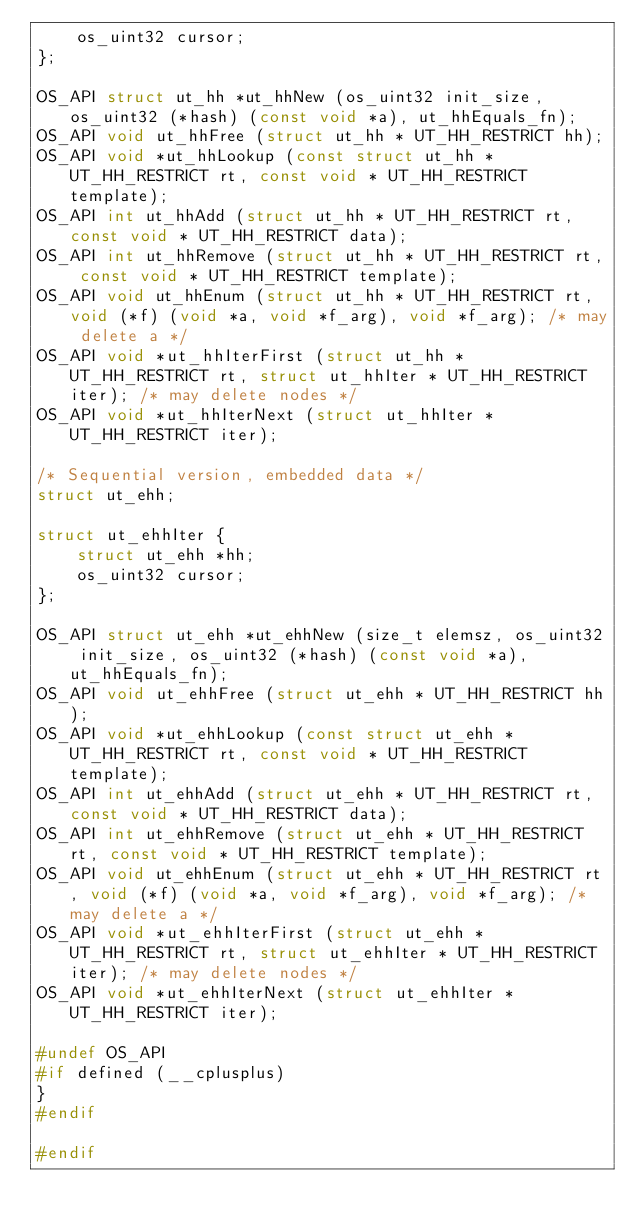<code> <loc_0><loc_0><loc_500><loc_500><_C_>    os_uint32 cursor;
};

OS_API struct ut_hh *ut_hhNew (os_uint32 init_size, os_uint32 (*hash) (const void *a), ut_hhEquals_fn);
OS_API void ut_hhFree (struct ut_hh * UT_HH_RESTRICT hh);
OS_API void *ut_hhLookup (const struct ut_hh * UT_HH_RESTRICT rt, const void * UT_HH_RESTRICT template);
OS_API int ut_hhAdd (struct ut_hh * UT_HH_RESTRICT rt, const void * UT_HH_RESTRICT data);
OS_API int ut_hhRemove (struct ut_hh * UT_HH_RESTRICT rt, const void * UT_HH_RESTRICT template);
OS_API void ut_hhEnum (struct ut_hh * UT_HH_RESTRICT rt, void (*f) (void *a, void *f_arg), void *f_arg); /* may delete a */
OS_API void *ut_hhIterFirst (struct ut_hh * UT_HH_RESTRICT rt, struct ut_hhIter * UT_HH_RESTRICT iter); /* may delete nodes */
OS_API void *ut_hhIterNext (struct ut_hhIter * UT_HH_RESTRICT iter);

/* Sequential version, embedded data */
struct ut_ehh;

struct ut_ehhIter {
    struct ut_ehh *hh;
    os_uint32 cursor;
};

OS_API struct ut_ehh *ut_ehhNew (size_t elemsz, os_uint32 init_size, os_uint32 (*hash) (const void *a), ut_hhEquals_fn);
OS_API void ut_ehhFree (struct ut_ehh * UT_HH_RESTRICT hh);
OS_API void *ut_ehhLookup (const struct ut_ehh * UT_HH_RESTRICT rt, const void * UT_HH_RESTRICT template);
OS_API int ut_ehhAdd (struct ut_ehh * UT_HH_RESTRICT rt, const void * UT_HH_RESTRICT data);
OS_API int ut_ehhRemove (struct ut_ehh * UT_HH_RESTRICT rt, const void * UT_HH_RESTRICT template);
OS_API void ut_ehhEnum (struct ut_ehh * UT_HH_RESTRICT rt, void (*f) (void *a, void *f_arg), void *f_arg); /* may delete a */
OS_API void *ut_ehhIterFirst (struct ut_ehh * UT_HH_RESTRICT rt, struct ut_ehhIter * UT_HH_RESTRICT iter); /* may delete nodes */
OS_API void *ut_ehhIterNext (struct ut_ehhIter * UT_HH_RESTRICT iter);

#undef OS_API
#if defined (__cplusplus)
}
#endif

#endif
</code> 